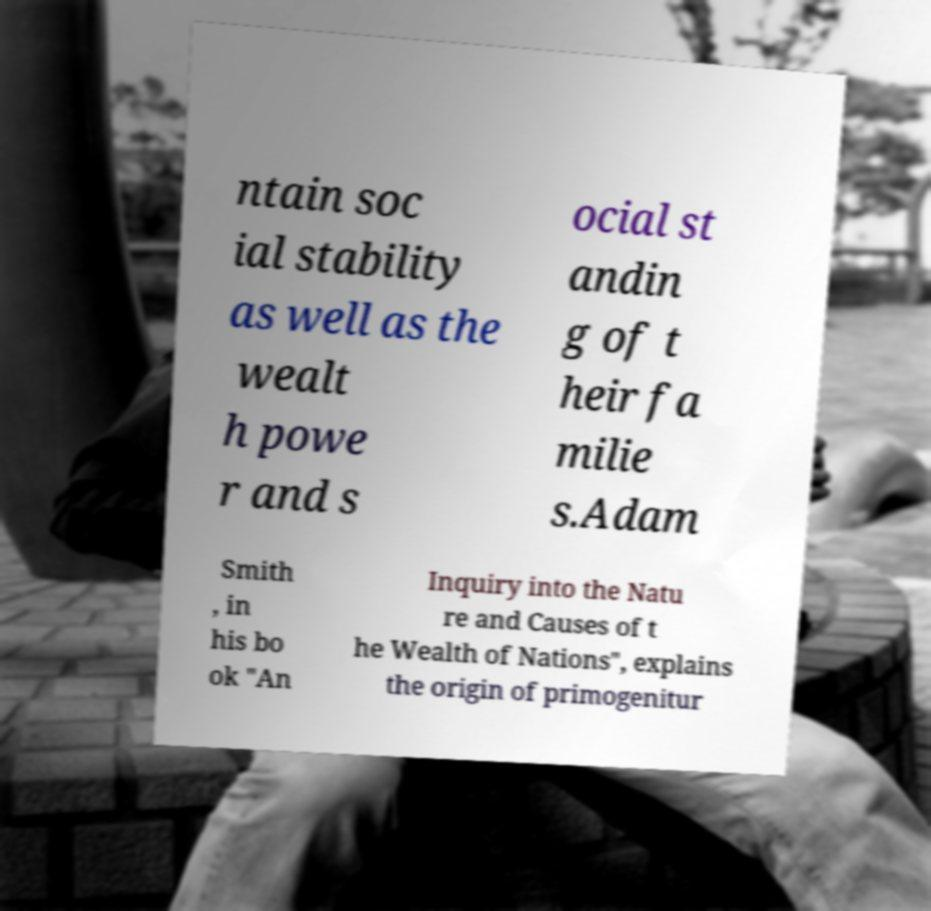Can you accurately transcribe the text from the provided image for me? ntain soc ial stability as well as the wealt h powe r and s ocial st andin g of t heir fa milie s.Adam Smith , in his bo ok "An Inquiry into the Natu re and Causes of t he Wealth of Nations", explains the origin of primogenitur 